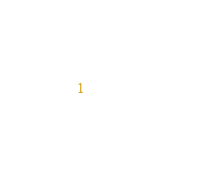<code> <loc_0><loc_0><loc_500><loc_500><_SQL_>            </code> 